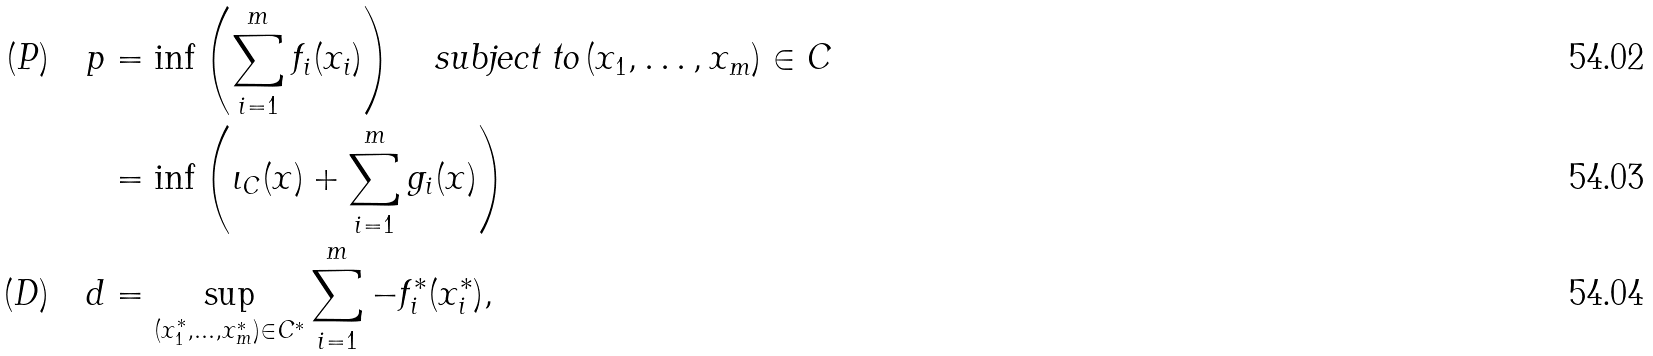<formula> <loc_0><loc_0><loc_500><loc_500>( P ) \quad p & = \inf \left ( \sum _ { i = 1 } ^ { m } f _ { i } ( x _ { i } ) \right ) \quad \text {subject to} \, ( x _ { 1 } , \dots , x _ { m } ) \in C \\ & = \inf \left ( \iota _ { C } ( x ) + \sum _ { i = 1 } ^ { m } g _ { i } ( x ) \right ) \\ ( D ) \quad d & = \sup _ { ( x ^ { * } _ { 1 } , \dots , x ^ { * } _ { m } ) \in C ^ { * } } \sum _ { i = 1 } ^ { m } - f ^ { * } _ { i } ( x _ { i } ^ { * } ) ,</formula> 